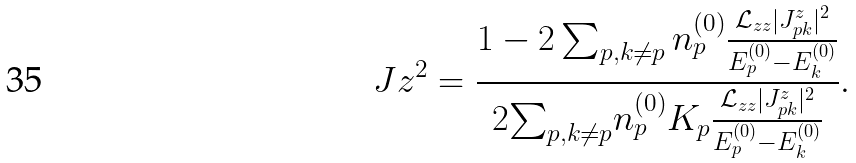Convert formula to latex. <formula><loc_0><loc_0><loc_500><loc_500>\ J z ^ { 2 } = \frac { 1 - 2 \sum _ { p , k \neq p } n _ { p } ^ { ( 0 ) } \frac { \mathcal { L } _ { z z } | J _ { p k } ^ { z } | ^ { 2 } } { E _ { p } ^ { ( 0 ) } - E _ { k } ^ { ( 0 ) } } } { 2 { \sum } _ { p , k \neq p } n _ { p } ^ { ( 0 ) } K _ { p } \frac { \mathcal { L } _ { z z } | J _ { p k } ^ { z } | ^ { 2 } } { E _ { p } ^ { ( 0 ) } - E _ { k } ^ { ( 0 ) } } } .</formula> 